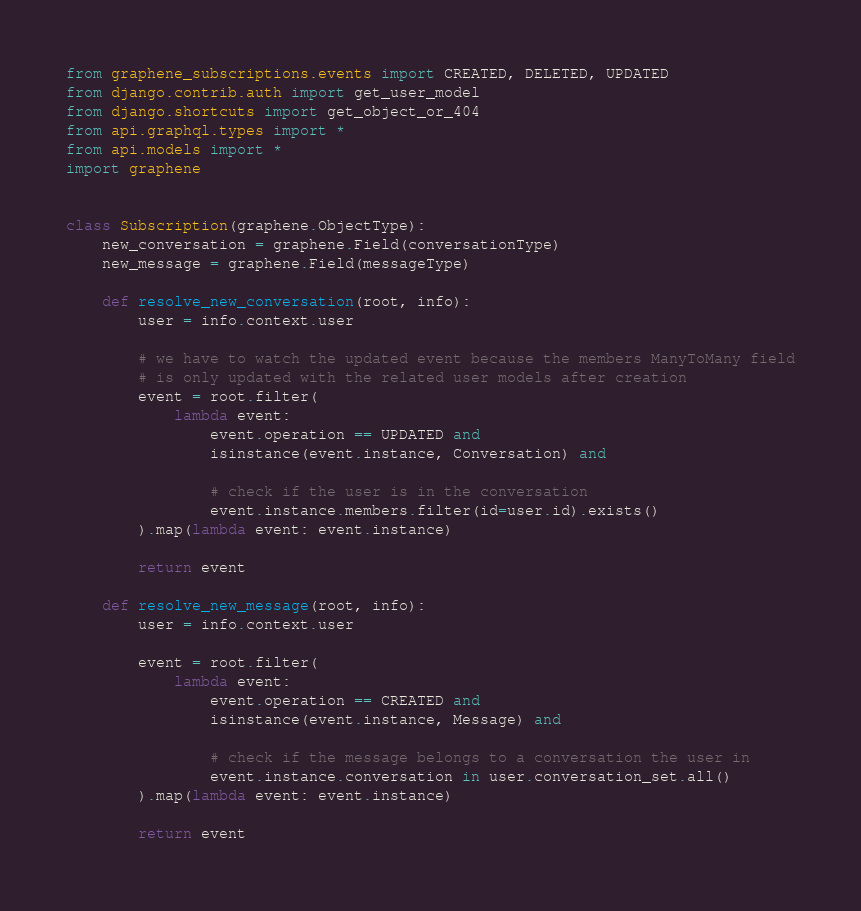<code> <loc_0><loc_0><loc_500><loc_500><_Python_>from graphene_subscriptions.events import CREATED, DELETED, UPDATED 
from django.contrib.auth import get_user_model
from django.shortcuts import get_object_or_404
from api.graphql.types import *
from api.models import *
import graphene


class Subscription(graphene.ObjectType):
    new_conversation = graphene.Field(conversationType)
    new_message = graphene.Field(messageType)

    def resolve_new_conversation(root, info):
        user = info.context.user
        
        # we have to watch the updated event because the members ManyToMany field
        # is only updated with the related user models after creation
        event = root.filter(
            lambda event:
                event.operation == UPDATED and
                isinstance(event.instance, Conversation) and

                # check if the user is in the conversation
                event.instance.members.filter(id=user.id).exists() 
        ).map(lambda event: event.instance)

        return event

    def resolve_new_message(root, info):
        user = info.context.user
        
        event = root.filter(
            lambda event:
                event.operation == CREATED and
                isinstance(event.instance, Message) and
                
                # check if the message belongs to a conversation the user in
                event.instance.conversation in user.conversation_set.all()
        ).map(lambda event: event.instance)

        return event</code> 